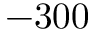<formula> <loc_0><loc_0><loc_500><loc_500>- 3 0 0</formula> 